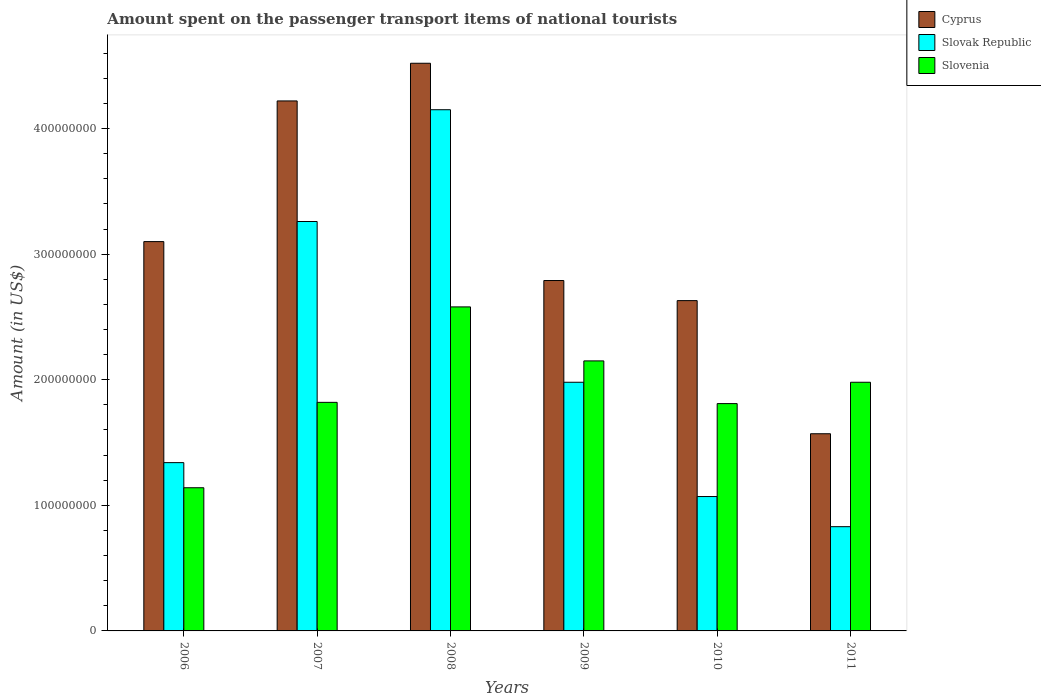How many different coloured bars are there?
Ensure brevity in your answer.  3. How many groups of bars are there?
Offer a terse response. 6. Are the number of bars on each tick of the X-axis equal?
Offer a terse response. Yes. How many bars are there on the 4th tick from the left?
Make the answer very short. 3. How many bars are there on the 1st tick from the right?
Make the answer very short. 3. In how many cases, is the number of bars for a given year not equal to the number of legend labels?
Your answer should be very brief. 0. What is the amount spent on the passenger transport items of national tourists in Slovenia in 2009?
Your answer should be very brief. 2.15e+08. Across all years, what is the maximum amount spent on the passenger transport items of national tourists in Cyprus?
Provide a succinct answer. 4.52e+08. Across all years, what is the minimum amount spent on the passenger transport items of national tourists in Slovenia?
Offer a terse response. 1.14e+08. In which year was the amount spent on the passenger transport items of national tourists in Slovenia maximum?
Offer a terse response. 2008. In which year was the amount spent on the passenger transport items of national tourists in Cyprus minimum?
Your answer should be compact. 2011. What is the total amount spent on the passenger transport items of national tourists in Slovak Republic in the graph?
Ensure brevity in your answer.  1.26e+09. What is the difference between the amount spent on the passenger transport items of national tourists in Slovak Republic in 2006 and that in 2009?
Your answer should be very brief. -6.40e+07. What is the difference between the amount spent on the passenger transport items of national tourists in Cyprus in 2010 and the amount spent on the passenger transport items of national tourists in Slovak Republic in 2006?
Ensure brevity in your answer.  1.29e+08. What is the average amount spent on the passenger transport items of national tourists in Slovak Republic per year?
Your answer should be compact. 2.10e+08. In the year 2011, what is the difference between the amount spent on the passenger transport items of national tourists in Slovak Republic and amount spent on the passenger transport items of national tourists in Slovenia?
Ensure brevity in your answer.  -1.15e+08. What is the ratio of the amount spent on the passenger transport items of national tourists in Slovak Republic in 2007 to that in 2009?
Your response must be concise. 1.65. Is the difference between the amount spent on the passenger transport items of national tourists in Slovak Republic in 2008 and 2011 greater than the difference between the amount spent on the passenger transport items of national tourists in Slovenia in 2008 and 2011?
Provide a short and direct response. Yes. What is the difference between the highest and the second highest amount spent on the passenger transport items of national tourists in Slovak Republic?
Give a very brief answer. 8.90e+07. What is the difference between the highest and the lowest amount spent on the passenger transport items of national tourists in Cyprus?
Provide a succinct answer. 2.95e+08. In how many years, is the amount spent on the passenger transport items of national tourists in Slovenia greater than the average amount spent on the passenger transport items of national tourists in Slovenia taken over all years?
Your answer should be compact. 3. Is the sum of the amount spent on the passenger transport items of national tourists in Slovak Republic in 2007 and 2011 greater than the maximum amount spent on the passenger transport items of national tourists in Slovenia across all years?
Your answer should be very brief. Yes. What does the 3rd bar from the left in 2007 represents?
Provide a succinct answer. Slovenia. What does the 1st bar from the right in 2006 represents?
Offer a very short reply. Slovenia. What is the difference between two consecutive major ticks on the Y-axis?
Your answer should be very brief. 1.00e+08. Are the values on the major ticks of Y-axis written in scientific E-notation?
Your response must be concise. No. Where does the legend appear in the graph?
Ensure brevity in your answer.  Top right. What is the title of the graph?
Offer a terse response. Amount spent on the passenger transport items of national tourists. Does "Panama" appear as one of the legend labels in the graph?
Give a very brief answer. No. What is the label or title of the X-axis?
Your response must be concise. Years. What is the label or title of the Y-axis?
Ensure brevity in your answer.  Amount (in US$). What is the Amount (in US$) in Cyprus in 2006?
Make the answer very short. 3.10e+08. What is the Amount (in US$) in Slovak Republic in 2006?
Give a very brief answer. 1.34e+08. What is the Amount (in US$) of Slovenia in 2006?
Provide a succinct answer. 1.14e+08. What is the Amount (in US$) of Cyprus in 2007?
Your answer should be very brief. 4.22e+08. What is the Amount (in US$) in Slovak Republic in 2007?
Provide a short and direct response. 3.26e+08. What is the Amount (in US$) in Slovenia in 2007?
Provide a short and direct response. 1.82e+08. What is the Amount (in US$) of Cyprus in 2008?
Keep it short and to the point. 4.52e+08. What is the Amount (in US$) in Slovak Republic in 2008?
Offer a very short reply. 4.15e+08. What is the Amount (in US$) of Slovenia in 2008?
Make the answer very short. 2.58e+08. What is the Amount (in US$) in Cyprus in 2009?
Provide a short and direct response. 2.79e+08. What is the Amount (in US$) of Slovak Republic in 2009?
Your response must be concise. 1.98e+08. What is the Amount (in US$) of Slovenia in 2009?
Provide a succinct answer. 2.15e+08. What is the Amount (in US$) of Cyprus in 2010?
Make the answer very short. 2.63e+08. What is the Amount (in US$) in Slovak Republic in 2010?
Make the answer very short. 1.07e+08. What is the Amount (in US$) in Slovenia in 2010?
Keep it short and to the point. 1.81e+08. What is the Amount (in US$) of Cyprus in 2011?
Keep it short and to the point. 1.57e+08. What is the Amount (in US$) in Slovak Republic in 2011?
Give a very brief answer. 8.30e+07. What is the Amount (in US$) of Slovenia in 2011?
Keep it short and to the point. 1.98e+08. Across all years, what is the maximum Amount (in US$) in Cyprus?
Ensure brevity in your answer.  4.52e+08. Across all years, what is the maximum Amount (in US$) in Slovak Republic?
Provide a succinct answer. 4.15e+08. Across all years, what is the maximum Amount (in US$) in Slovenia?
Your response must be concise. 2.58e+08. Across all years, what is the minimum Amount (in US$) of Cyprus?
Your answer should be very brief. 1.57e+08. Across all years, what is the minimum Amount (in US$) of Slovak Republic?
Your response must be concise. 8.30e+07. Across all years, what is the minimum Amount (in US$) in Slovenia?
Offer a very short reply. 1.14e+08. What is the total Amount (in US$) of Cyprus in the graph?
Make the answer very short. 1.88e+09. What is the total Amount (in US$) in Slovak Republic in the graph?
Give a very brief answer. 1.26e+09. What is the total Amount (in US$) of Slovenia in the graph?
Your answer should be very brief. 1.15e+09. What is the difference between the Amount (in US$) of Cyprus in 2006 and that in 2007?
Your answer should be compact. -1.12e+08. What is the difference between the Amount (in US$) in Slovak Republic in 2006 and that in 2007?
Make the answer very short. -1.92e+08. What is the difference between the Amount (in US$) in Slovenia in 2006 and that in 2007?
Provide a short and direct response. -6.80e+07. What is the difference between the Amount (in US$) of Cyprus in 2006 and that in 2008?
Your answer should be compact. -1.42e+08. What is the difference between the Amount (in US$) of Slovak Republic in 2006 and that in 2008?
Your answer should be compact. -2.81e+08. What is the difference between the Amount (in US$) of Slovenia in 2006 and that in 2008?
Your answer should be very brief. -1.44e+08. What is the difference between the Amount (in US$) of Cyprus in 2006 and that in 2009?
Keep it short and to the point. 3.10e+07. What is the difference between the Amount (in US$) of Slovak Republic in 2006 and that in 2009?
Offer a terse response. -6.40e+07. What is the difference between the Amount (in US$) in Slovenia in 2006 and that in 2009?
Ensure brevity in your answer.  -1.01e+08. What is the difference between the Amount (in US$) of Cyprus in 2006 and that in 2010?
Provide a short and direct response. 4.70e+07. What is the difference between the Amount (in US$) in Slovak Republic in 2006 and that in 2010?
Your answer should be very brief. 2.70e+07. What is the difference between the Amount (in US$) in Slovenia in 2006 and that in 2010?
Offer a very short reply. -6.70e+07. What is the difference between the Amount (in US$) of Cyprus in 2006 and that in 2011?
Offer a very short reply. 1.53e+08. What is the difference between the Amount (in US$) in Slovak Republic in 2006 and that in 2011?
Ensure brevity in your answer.  5.10e+07. What is the difference between the Amount (in US$) of Slovenia in 2006 and that in 2011?
Keep it short and to the point. -8.40e+07. What is the difference between the Amount (in US$) in Cyprus in 2007 and that in 2008?
Your answer should be compact. -3.00e+07. What is the difference between the Amount (in US$) of Slovak Republic in 2007 and that in 2008?
Give a very brief answer. -8.90e+07. What is the difference between the Amount (in US$) of Slovenia in 2007 and that in 2008?
Your answer should be compact. -7.60e+07. What is the difference between the Amount (in US$) in Cyprus in 2007 and that in 2009?
Your answer should be compact. 1.43e+08. What is the difference between the Amount (in US$) in Slovak Republic in 2007 and that in 2009?
Offer a very short reply. 1.28e+08. What is the difference between the Amount (in US$) in Slovenia in 2007 and that in 2009?
Give a very brief answer. -3.30e+07. What is the difference between the Amount (in US$) of Cyprus in 2007 and that in 2010?
Keep it short and to the point. 1.59e+08. What is the difference between the Amount (in US$) of Slovak Republic in 2007 and that in 2010?
Your answer should be very brief. 2.19e+08. What is the difference between the Amount (in US$) of Cyprus in 2007 and that in 2011?
Offer a very short reply. 2.65e+08. What is the difference between the Amount (in US$) of Slovak Republic in 2007 and that in 2011?
Offer a terse response. 2.43e+08. What is the difference between the Amount (in US$) in Slovenia in 2007 and that in 2011?
Provide a succinct answer. -1.60e+07. What is the difference between the Amount (in US$) in Cyprus in 2008 and that in 2009?
Your response must be concise. 1.73e+08. What is the difference between the Amount (in US$) of Slovak Republic in 2008 and that in 2009?
Offer a very short reply. 2.17e+08. What is the difference between the Amount (in US$) of Slovenia in 2008 and that in 2009?
Provide a short and direct response. 4.30e+07. What is the difference between the Amount (in US$) in Cyprus in 2008 and that in 2010?
Ensure brevity in your answer.  1.89e+08. What is the difference between the Amount (in US$) in Slovak Republic in 2008 and that in 2010?
Make the answer very short. 3.08e+08. What is the difference between the Amount (in US$) in Slovenia in 2008 and that in 2010?
Give a very brief answer. 7.70e+07. What is the difference between the Amount (in US$) in Cyprus in 2008 and that in 2011?
Provide a short and direct response. 2.95e+08. What is the difference between the Amount (in US$) in Slovak Republic in 2008 and that in 2011?
Provide a short and direct response. 3.32e+08. What is the difference between the Amount (in US$) in Slovenia in 2008 and that in 2011?
Offer a terse response. 6.00e+07. What is the difference between the Amount (in US$) in Cyprus in 2009 and that in 2010?
Make the answer very short. 1.60e+07. What is the difference between the Amount (in US$) in Slovak Republic in 2009 and that in 2010?
Give a very brief answer. 9.10e+07. What is the difference between the Amount (in US$) of Slovenia in 2009 and that in 2010?
Provide a succinct answer. 3.40e+07. What is the difference between the Amount (in US$) in Cyprus in 2009 and that in 2011?
Provide a succinct answer. 1.22e+08. What is the difference between the Amount (in US$) in Slovak Republic in 2009 and that in 2011?
Keep it short and to the point. 1.15e+08. What is the difference between the Amount (in US$) of Slovenia in 2009 and that in 2011?
Ensure brevity in your answer.  1.70e+07. What is the difference between the Amount (in US$) of Cyprus in 2010 and that in 2011?
Provide a succinct answer. 1.06e+08. What is the difference between the Amount (in US$) of Slovak Republic in 2010 and that in 2011?
Make the answer very short. 2.40e+07. What is the difference between the Amount (in US$) of Slovenia in 2010 and that in 2011?
Provide a succinct answer. -1.70e+07. What is the difference between the Amount (in US$) in Cyprus in 2006 and the Amount (in US$) in Slovak Republic in 2007?
Provide a short and direct response. -1.60e+07. What is the difference between the Amount (in US$) of Cyprus in 2006 and the Amount (in US$) of Slovenia in 2007?
Make the answer very short. 1.28e+08. What is the difference between the Amount (in US$) of Slovak Republic in 2006 and the Amount (in US$) of Slovenia in 2007?
Your response must be concise. -4.80e+07. What is the difference between the Amount (in US$) in Cyprus in 2006 and the Amount (in US$) in Slovak Republic in 2008?
Offer a very short reply. -1.05e+08. What is the difference between the Amount (in US$) in Cyprus in 2006 and the Amount (in US$) in Slovenia in 2008?
Make the answer very short. 5.20e+07. What is the difference between the Amount (in US$) in Slovak Republic in 2006 and the Amount (in US$) in Slovenia in 2008?
Keep it short and to the point. -1.24e+08. What is the difference between the Amount (in US$) in Cyprus in 2006 and the Amount (in US$) in Slovak Republic in 2009?
Your answer should be compact. 1.12e+08. What is the difference between the Amount (in US$) in Cyprus in 2006 and the Amount (in US$) in Slovenia in 2009?
Your response must be concise. 9.50e+07. What is the difference between the Amount (in US$) in Slovak Republic in 2006 and the Amount (in US$) in Slovenia in 2009?
Provide a succinct answer. -8.10e+07. What is the difference between the Amount (in US$) in Cyprus in 2006 and the Amount (in US$) in Slovak Republic in 2010?
Offer a terse response. 2.03e+08. What is the difference between the Amount (in US$) in Cyprus in 2006 and the Amount (in US$) in Slovenia in 2010?
Provide a succinct answer. 1.29e+08. What is the difference between the Amount (in US$) in Slovak Republic in 2006 and the Amount (in US$) in Slovenia in 2010?
Offer a terse response. -4.70e+07. What is the difference between the Amount (in US$) of Cyprus in 2006 and the Amount (in US$) of Slovak Republic in 2011?
Provide a succinct answer. 2.27e+08. What is the difference between the Amount (in US$) of Cyprus in 2006 and the Amount (in US$) of Slovenia in 2011?
Your answer should be very brief. 1.12e+08. What is the difference between the Amount (in US$) of Slovak Republic in 2006 and the Amount (in US$) of Slovenia in 2011?
Offer a very short reply. -6.40e+07. What is the difference between the Amount (in US$) of Cyprus in 2007 and the Amount (in US$) of Slovenia in 2008?
Provide a succinct answer. 1.64e+08. What is the difference between the Amount (in US$) in Slovak Republic in 2007 and the Amount (in US$) in Slovenia in 2008?
Keep it short and to the point. 6.80e+07. What is the difference between the Amount (in US$) of Cyprus in 2007 and the Amount (in US$) of Slovak Republic in 2009?
Your answer should be very brief. 2.24e+08. What is the difference between the Amount (in US$) in Cyprus in 2007 and the Amount (in US$) in Slovenia in 2009?
Ensure brevity in your answer.  2.07e+08. What is the difference between the Amount (in US$) in Slovak Republic in 2007 and the Amount (in US$) in Slovenia in 2009?
Offer a terse response. 1.11e+08. What is the difference between the Amount (in US$) of Cyprus in 2007 and the Amount (in US$) of Slovak Republic in 2010?
Make the answer very short. 3.15e+08. What is the difference between the Amount (in US$) in Cyprus in 2007 and the Amount (in US$) in Slovenia in 2010?
Your answer should be very brief. 2.41e+08. What is the difference between the Amount (in US$) of Slovak Republic in 2007 and the Amount (in US$) of Slovenia in 2010?
Offer a terse response. 1.45e+08. What is the difference between the Amount (in US$) in Cyprus in 2007 and the Amount (in US$) in Slovak Republic in 2011?
Offer a terse response. 3.39e+08. What is the difference between the Amount (in US$) of Cyprus in 2007 and the Amount (in US$) of Slovenia in 2011?
Offer a very short reply. 2.24e+08. What is the difference between the Amount (in US$) of Slovak Republic in 2007 and the Amount (in US$) of Slovenia in 2011?
Offer a very short reply. 1.28e+08. What is the difference between the Amount (in US$) of Cyprus in 2008 and the Amount (in US$) of Slovak Republic in 2009?
Your response must be concise. 2.54e+08. What is the difference between the Amount (in US$) in Cyprus in 2008 and the Amount (in US$) in Slovenia in 2009?
Provide a succinct answer. 2.37e+08. What is the difference between the Amount (in US$) in Slovak Republic in 2008 and the Amount (in US$) in Slovenia in 2009?
Your answer should be very brief. 2.00e+08. What is the difference between the Amount (in US$) of Cyprus in 2008 and the Amount (in US$) of Slovak Republic in 2010?
Keep it short and to the point. 3.45e+08. What is the difference between the Amount (in US$) of Cyprus in 2008 and the Amount (in US$) of Slovenia in 2010?
Your answer should be compact. 2.71e+08. What is the difference between the Amount (in US$) in Slovak Republic in 2008 and the Amount (in US$) in Slovenia in 2010?
Offer a very short reply. 2.34e+08. What is the difference between the Amount (in US$) of Cyprus in 2008 and the Amount (in US$) of Slovak Republic in 2011?
Offer a very short reply. 3.69e+08. What is the difference between the Amount (in US$) of Cyprus in 2008 and the Amount (in US$) of Slovenia in 2011?
Your answer should be very brief. 2.54e+08. What is the difference between the Amount (in US$) in Slovak Republic in 2008 and the Amount (in US$) in Slovenia in 2011?
Keep it short and to the point. 2.17e+08. What is the difference between the Amount (in US$) of Cyprus in 2009 and the Amount (in US$) of Slovak Republic in 2010?
Provide a succinct answer. 1.72e+08. What is the difference between the Amount (in US$) of Cyprus in 2009 and the Amount (in US$) of Slovenia in 2010?
Offer a very short reply. 9.80e+07. What is the difference between the Amount (in US$) of Slovak Republic in 2009 and the Amount (in US$) of Slovenia in 2010?
Ensure brevity in your answer.  1.70e+07. What is the difference between the Amount (in US$) of Cyprus in 2009 and the Amount (in US$) of Slovak Republic in 2011?
Keep it short and to the point. 1.96e+08. What is the difference between the Amount (in US$) of Cyprus in 2009 and the Amount (in US$) of Slovenia in 2011?
Your answer should be compact. 8.10e+07. What is the difference between the Amount (in US$) of Cyprus in 2010 and the Amount (in US$) of Slovak Republic in 2011?
Provide a succinct answer. 1.80e+08. What is the difference between the Amount (in US$) in Cyprus in 2010 and the Amount (in US$) in Slovenia in 2011?
Offer a very short reply. 6.50e+07. What is the difference between the Amount (in US$) in Slovak Republic in 2010 and the Amount (in US$) in Slovenia in 2011?
Your answer should be compact. -9.10e+07. What is the average Amount (in US$) of Cyprus per year?
Offer a very short reply. 3.14e+08. What is the average Amount (in US$) in Slovak Republic per year?
Provide a short and direct response. 2.10e+08. What is the average Amount (in US$) in Slovenia per year?
Make the answer very short. 1.91e+08. In the year 2006, what is the difference between the Amount (in US$) of Cyprus and Amount (in US$) of Slovak Republic?
Ensure brevity in your answer.  1.76e+08. In the year 2006, what is the difference between the Amount (in US$) of Cyprus and Amount (in US$) of Slovenia?
Give a very brief answer. 1.96e+08. In the year 2006, what is the difference between the Amount (in US$) of Slovak Republic and Amount (in US$) of Slovenia?
Your response must be concise. 2.00e+07. In the year 2007, what is the difference between the Amount (in US$) of Cyprus and Amount (in US$) of Slovak Republic?
Ensure brevity in your answer.  9.60e+07. In the year 2007, what is the difference between the Amount (in US$) in Cyprus and Amount (in US$) in Slovenia?
Offer a very short reply. 2.40e+08. In the year 2007, what is the difference between the Amount (in US$) in Slovak Republic and Amount (in US$) in Slovenia?
Provide a short and direct response. 1.44e+08. In the year 2008, what is the difference between the Amount (in US$) of Cyprus and Amount (in US$) of Slovak Republic?
Offer a terse response. 3.70e+07. In the year 2008, what is the difference between the Amount (in US$) in Cyprus and Amount (in US$) in Slovenia?
Offer a terse response. 1.94e+08. In the year 2008, what is the difference between the Amount (in US$) of Slovak Republic and Amount (in US$) of Slovenia?
Your answer should be compact. 1.57e+08. In the year 2009, what is the difference between the Amount (in US$) in Cyprus and Amount (in US$) in Slovak Republic?
Make the answer very short. 8.10e+07. In the year 2009, what is the difference between the Amount (in US$) in Cyprus and Amount (in US$) in Slovenia?
Your answer should be very brief. 6.40e+07. In the year 2009, what is the difference between the Amount (in US$) of Slovak Republic and Amount (in US$) of Slovenia?
Your answer should be very brief. -1.70e+07. In the year 2010, what is the difference between the Amount (in US$) of Cyprus and Amount (in US$) of Slovak Republic?
Give a very brief answer. 1.56e+08. In the year 2010, what is the difference between the Amount (in US$) in Cyprus and Amount (in US$) in Slovenia?
Offer a very short reply. 8.20e+07. In the year 2010, what is the difference between the Amount (in US$) in Slovak Republic and Amount (in US$) in Slovenia?
Your answer should be compact. -7.40e+07. In the year 2011, what is the difference between the Amount (in US$) in Cyprus and Amount (in US$) in Slovak Republic?
Provide a succinct answer. 7.40e+07. In the year 2011, what is the difference between the Amount (in US$) in Cyprus and Amount (in US$) in Slovenia?
Offer a terse response. -4.10e+07. In the year 2011, what is the difference between the Amount (in US$) of Slovak Republic and Amount (in US$) of Slovenia?
Your answer should be compact. -1.15e+08. What is the ratio of the Amount (in US$) in Cyprus in 2006 to that in 2007?
Offer a terse response. 0.73. What is the ratio of the Amount (in US$) in Slovak Republic in 2006 to that in 2007?
Offer a very short reply. 0.41. What is the ratio of the Amount (in US$) of Slovenia in 2006 to that in 2007?
Your answer should be very brief. 0.63. What is the ratio of the Amount (in US$) of Cyprus in 2006 to that in 2008?
Keep it short and to the point. 0.69. What is the ratio of the Amount (in US$) of Slovak Republic in 2006 to that in 2008?
Ensure brevity in your answer.  0.32. What is the ratio of the Amount (in US$) of Slovenia in 2006 to that in 2008?
Ensure brevity in your answer.  0.44. What is the ratio of the Amount (in US$) in Cyprus in 2006 to that in 2009?
Offer a very short reply. 1.11. What is the ratio of the Amount (in US$) of Slovak Republic in 2006 to that in 2009?
Provide a succinct answer. 0.68. What is the ratio of the Amount (in US$) in Slovenia in 2006 to that in 2009?
Provide a short and direct response. 0.53. What is the ratio of the Amount (in US$) of Cyprus in 2006 to that in 2010?
Your answer should be very brief. 1.18. What is the ratio of the Amount (in US$) in Slovak Republic in 2006 to that in 2010?
Give a very brief answer. 1.25. What is the ratio of the Amount (in US$) in Slovenia in 2006 to that in 2010?
Provide a short and direct response. 0.63. What is the ratio of the Amount (in US$) of Cyprus in 2006 to that in 2011?
Your response must be concise. 1.97. What is the ratio of the Amount (in US$) of Slovak Republic in 2006 to that in 2011?
Offer a very short reply. 1.61. What is the ratio of the Amount (in US$) of Slovenia in 2006 to that in 2011?
Provide a short and direct response. 0.58. What is the ratio of the Amount (in US$) in Cyprus in 2007 to that in 2008?
Make the answer very short. 0.93. What is the ratio of the Amount (in US$) in Slovak Republic in 2007 to that in 2008?
Your response must be concise. 0.79. What is the ratio of the Amount (in US$) of Slovenia in 2007 to that in 2008?
Ensure brevity in your answer.  0.71. What is the ratio of the Amount (in US$) of Cyprus in 2007 to that in 2009?
Your answer should be very brief. 1.51. What is the ratio of the Amount (in US$) of Slovak Republic in 2007 to that in 2009?
Ensure brevity in your answer.  1.65. What is the ratio of the Amount (in US$) of Slovenia in 2007 to that in 2009?
Provide a succinct answer. 0.85. What is the ratio of the Amount (in US$) in Cyprus in 2007 to that in 2010?
Make the answer very short. 1.6. What is the ratio of the Amount (in US$) of Slovak Republic in 2007 to that in 2010?
Ensure brevity in your answer.  3.05. What is the ratio of the Amount (in US$) of Cyprus in 2007 to that in 2011?
Your answer should be very brief. 2.69. What is the ratio of the Amount (in US$) of Slovak Republic in 2007 to that in 2011?
Keep it short and to the point. 3.93. What is the ratio of the Amount (in US$) of Slovenia in 2007 to that in 2011?
Your answer should be compact. 0.92. What is the ratio of the Amount (in US$) in Cyprus in 2008 to that in 2009?
Make the answer very short. 1.62. What is the ratio of the Amount (in US$) in Slovak Republic in 2008 to that in 2009?
Offer a terse response. 2.1. What is the ratio of the Amount (in US$) of Slovenia in 2008 to that in 2009?
Provide a succinct answer. 1.2. What is the ratio of the Amount (in US$) in Cyprus in 2008 to that in 2010?
Provide a short and direct response. 1.72. What is the ratio of the Amount (in US$) of Slovak Republic in 2008 to that in 2010?
Provide a short and direct response. 3.88. What is the ratio of the Amount (in US$) of Slovenia in 2008 to that in 2010?
Your response must be concise. 1.43. What is the ratio of the Amount (in US$) of Cyprus in 2008 to that in 2011?
Make the answer very short. 2.88. What is the ratio of the Amount (in US$) of Slovak Republic in 2008 to that in 2011?
Your response must be concise. 5. What is the ratio of the Amount (in US$) of Slovenia in 2008 to that in 2011?
Keep it short and to the point. 1.3. What is the ratio of the Amount (in US$) of Cyprus in 2009 to that in 2010?
Ensure brevity in your answer.  1.06. What is the ratio of the Amount (in US$) in Slovak Republic in 2009 to that in 2010?
Give a very brief answer. 1.85. What is the ratio of the Amount (in US$) in Slovenia in 2009 to that in 2010?
Provide a succinct answer. 1.19. What is the ratio of the Amount (in US$) in Cyprus in 2009 to that in 2011?
Provide a short and direct response. 1.78. What is the ratio of the Amount (in US$) in Slovak Republic in 2009 to that in 2011?
Keep it short and to the point. 2.39. What is the ratio of the Amount (in US$) of Slovenia in 2009 to that in 2011?
Give a very brief answer. 1.09. What is the ratio of the Amount (in US$) in Cyprus in 2010 to that in 2011?
Keep it short and to the point. 1.68. What is the ratio of the Amount (in US$) in Slovak Republic in 2010 to that in 2011?
Offer a very short reply. 1.29. What is the ratio of the Amount (in US$) of Slovenia in 2010 to that in 2011?
Your answer should be very brief. 0.91. What is the difference between the highest and the second highest Amount (in US$) of Cyprus?
Provide a succinct answer. 3.00e+07. What is the difference between the highest and the second highest Amount (in US$) in Slovak Republic?
Provide a short and direct response. 8.90e+07. What is the difference between the highest and the second highest Amount (in US$) of Slovenia?
Offer a terse response. 4.30e+07. What is the difference between the highest and the lowest Amount (in US$) of Cyprus?
Offer a very short reply. 2.95e+08. What is the difference between the highest and the lowest Amount (in US$) of Slovak Republic?
Offer a terse response. 3.32e+08. What is the difference between the highest and the lowest Amount (in US$) of Slovenia?
Offer a terse response. 1.44e+08. 